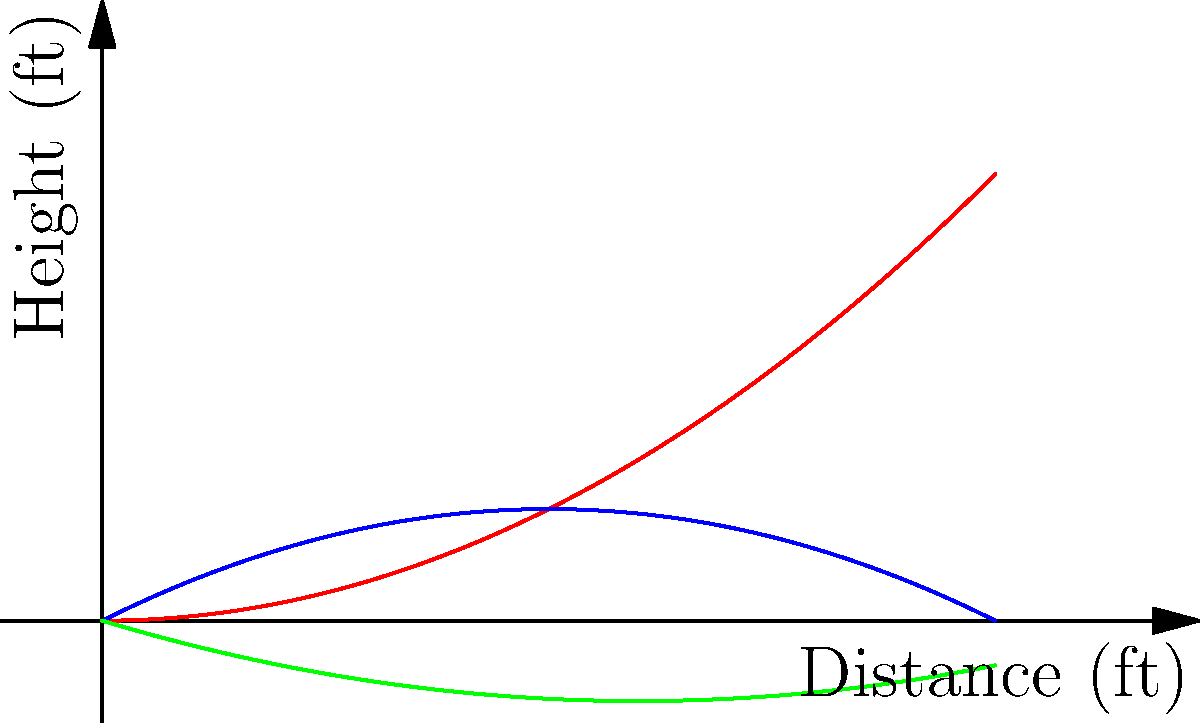In the context of the 2008 financial crisis's impact on local sports, consider the trajectories of different baseball pitches shown in the graph. Which pitch type would be most likely to result in a ground ball, potentially leading to a double play that could quickly end an inning and save a struggling pitcher's energy? To answer this question, we need to analyze the trajectories of the three pitch types shown in the graph:

1. Fastball (red line): This pitch has a consistently upward trajectory, ending at the highest point.
2. Curveball (blue line): This pitch starts with an upward trajectory but then curves downward, ending at a lower point than where it started.
3. Slider (green line): This pitch has a predominantly downward trajectory, ending at the lowest point among all three pitches.

Step-by-step analysis:
1. A ground ball is more likely to occur when a pitch ends at a lower point, making it harder for the batter to lift the ball.
2. The slider (green line) has the steepest downward trajectory and ends at the lowest point.
3. This downward movement increases the chances of the batter hitting the top of the ball, resulting in a ground ball.
4. Ground balls are often favorable for inducing double plays, which can quickly end an inning.
5. In the context of the 2008 financial crisis, efficient pitching could help struggling teams save resources and energy, which might be particularly important for budget-conscious local teams.

Therefore, the slider is most likely to result in a ground ball, potentially leading to a double play and helping a struggling pitcher conserve energy.
Answer: Slider 